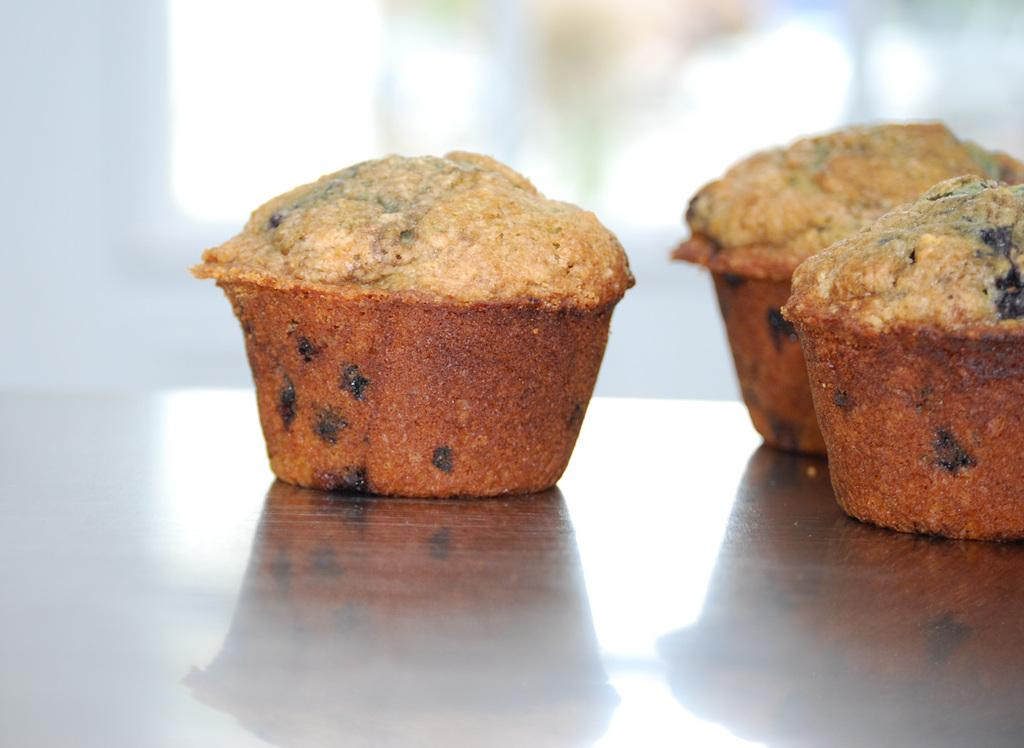What is the main subject of the image? The main subject of the image is food placed on a table. What can be observed about the color of the food? The food is in brown color. What type of food does the image appear to depict? The food resembles cupcakes. Is there a drain visible in the image? No, there is no drain present in the image. What type of wrist support is provided for the cupcakes in the image? There is no wrist support mentioned or visible in the image; it only shows food resembling cupcakes placed on a table. 